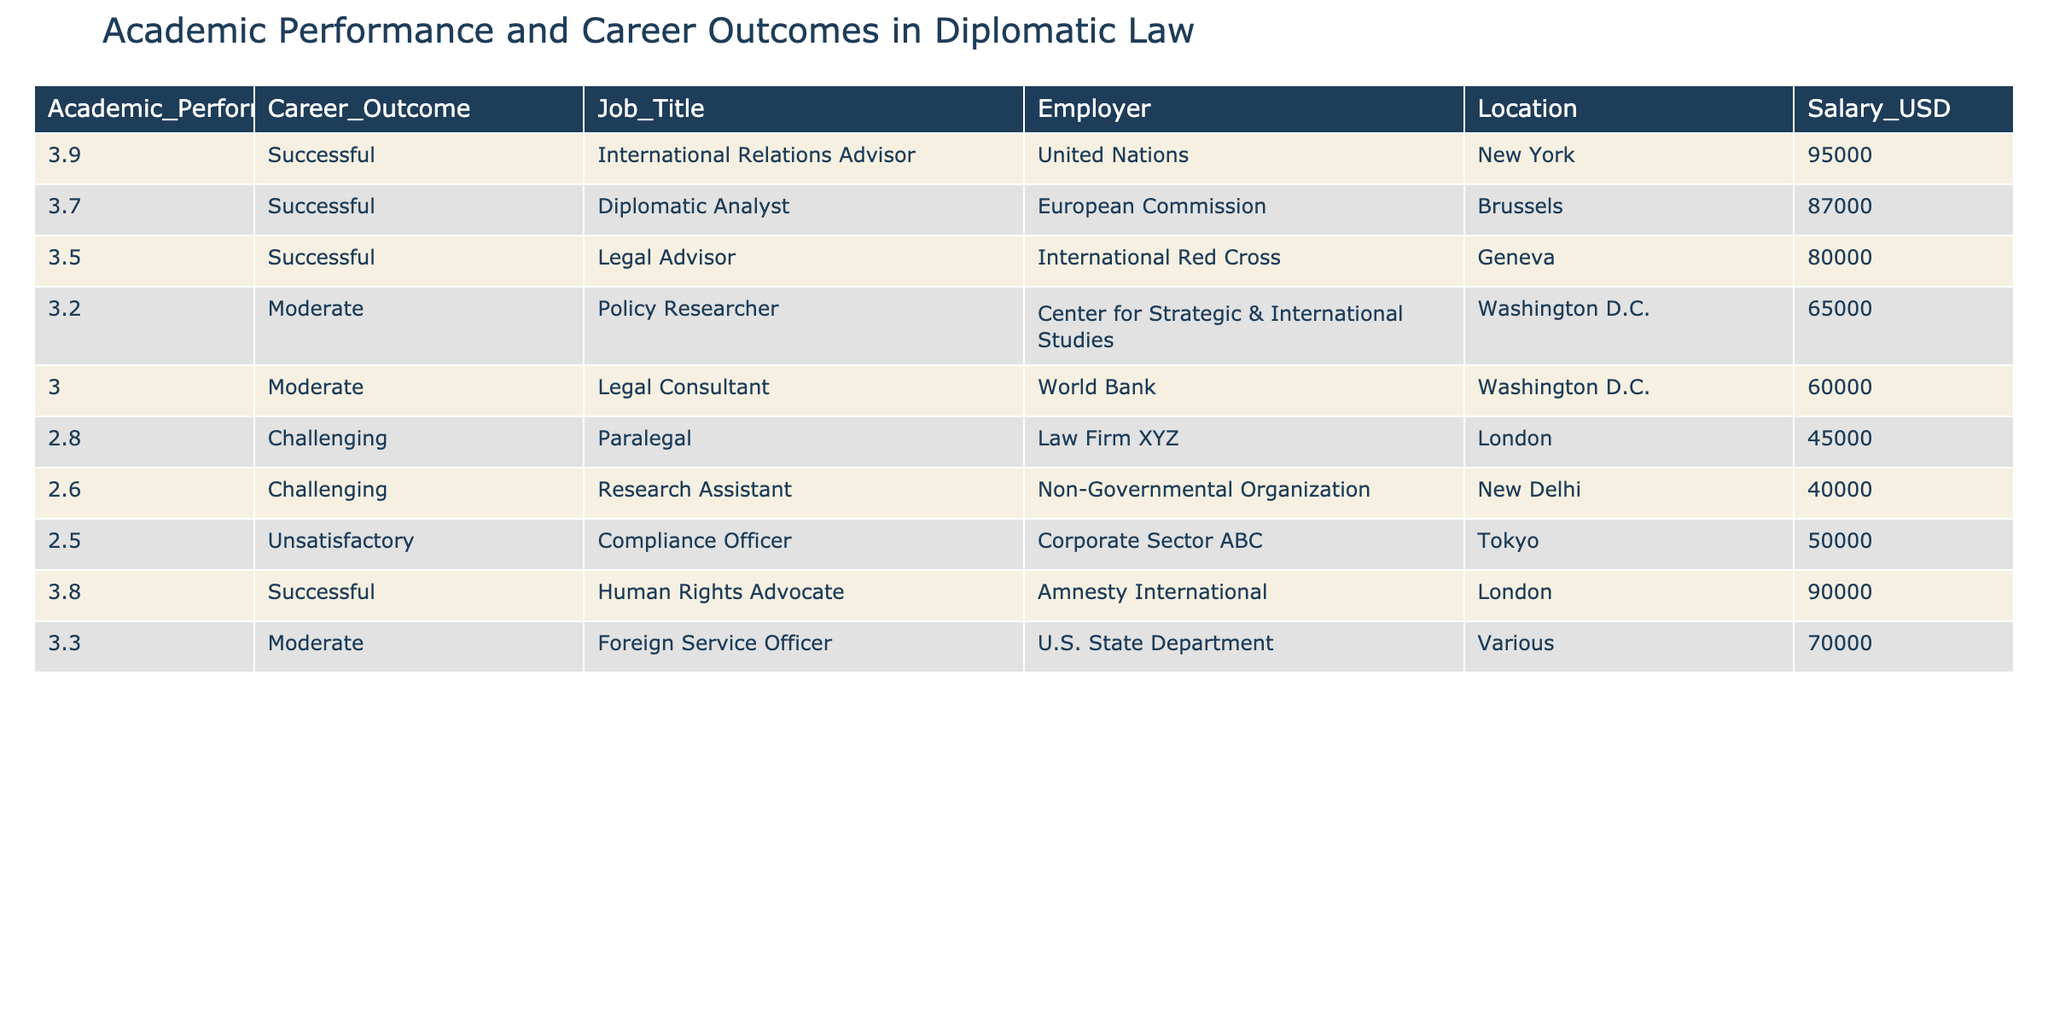What is the job title of the student with the highest academic performance? The highest academic performance listed in the table is 3.9. Looking at the table, the job title corresponding to this GPA is "International Relations Advisor."
Answer: International Relations Advisor What is the average salary of students with a successful career outcome? To calculate the average salary for those marked as successful, we sum the salaries: 95000 + 87000 + 80000 + 90000 = 351000. Since there are 4 successful outcomes, the average salary is 351000 / 4 = 87750.
Answer: 87750 Is there a job title associated with an academic performance of 2.0 or lower? In the table, the lowest academic performance listed is 2.5, which corresponds to the job title "Compliance Officer." Therefore, there are no job titles associated with a performance of 2.0 or lower.
Answer: No What is the difference in salary between the highest and lowest paying job titles? The highest paying job title is "International Relations Advisor" with a salary of 95000, and the lowest is "Research Assistant" with a salary of 40000. The difference is 95000 - 40000 = 55000.
Answer: 55000 How many students were able to achieve a moderate career outcome? The table lists three entries with a moderate career outcome: "Policy Researcher," "Legal Consultant," and "Foreign Service Officer." Therefore, the total is 3 students.
Answer: 3 What is the average academic performance of students employed by international organizations? The students employed by international organizations are "Legal Advisor" (3.5), "Human Rights Advocate" (3.8), and "International Relations Advisor" (3.9). Summing these academic performances, we have 3.5 + 3.8 + 3.9 = 11.2, and averaging this by dividing by 3 gives us 11.2 / 3 = 3.733.
Answer: 3.733 Did more students work in Washington D.C. than in New York? In the table, there are two students working in Washington D.C. ("Policy Researcher" and "Legal Consultant") and one working in New York ("International Relations Advisor"). Therefore, more students worked in Washington D.C.
Answer: Yes What job title is associated with the second lowest academic performance? The second lowest academic performance listed in the table is 2.6, which corresponds to the job title "Research Assistant."
Answer: Research Assistant What is the total number of students who have been successful? The table lists four successful career outcomes: "International Relations Advisor," "Diplomatic Analyst," "Legal Advisor," and "Human Rights Advocate." Hence, the total is 4.
Answer: 4 